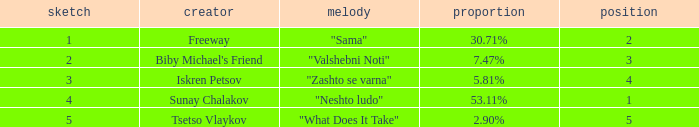What is the highest draw when the place is less than 3 and the percentage is 30.71%? 1.0. I'm looking to parse the entire table for insights. Could you assist me with that? {'header': ['sketch', 'creator', 'melody', 'proportion', 'position'], 'rows': [['1', 'Freeway', '"Sama"', '30.71%', '2'], ['2', "Biby Michael's Friend", '"Valshebni Noti"', '7.47%', '3'], ['3', 'Iskren Petsov', '"Zashto se varna"', '5.81%', '4'], ['4', 'Sunay Chalakov', '"Neshto ludo"', '53.11%', '1'], ['5', 'Tsetso Vlaykov', '"What Does It Take"', '2.90%', '5']]} 